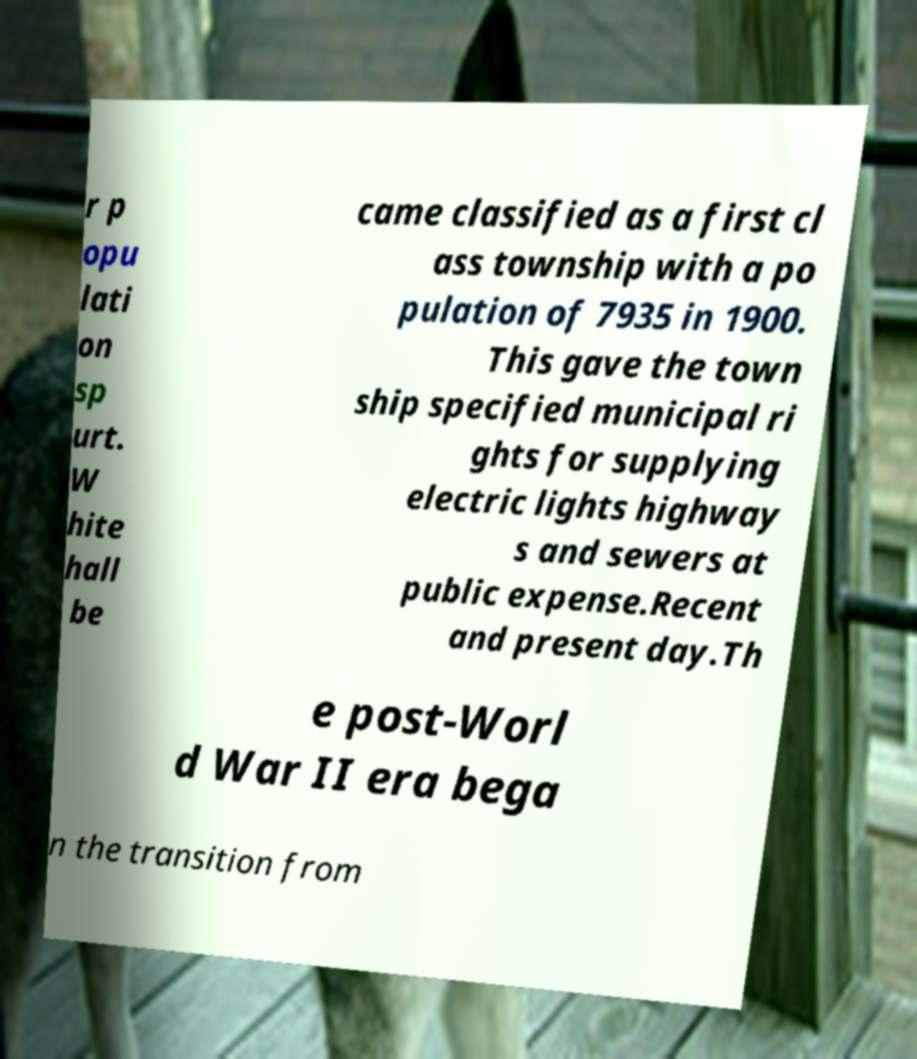Could you extract and type out the text from this image? r p opu lati on sp urt. W hite hall be came classified as a first cl ass township with a po pulation of 7935 in 1900. This gave the town ship specified municipal ri ghts for supplying electric lights highway s and sewers at public expense.Recent and present day.Th e post-Worl d War II era bega n the transition from 